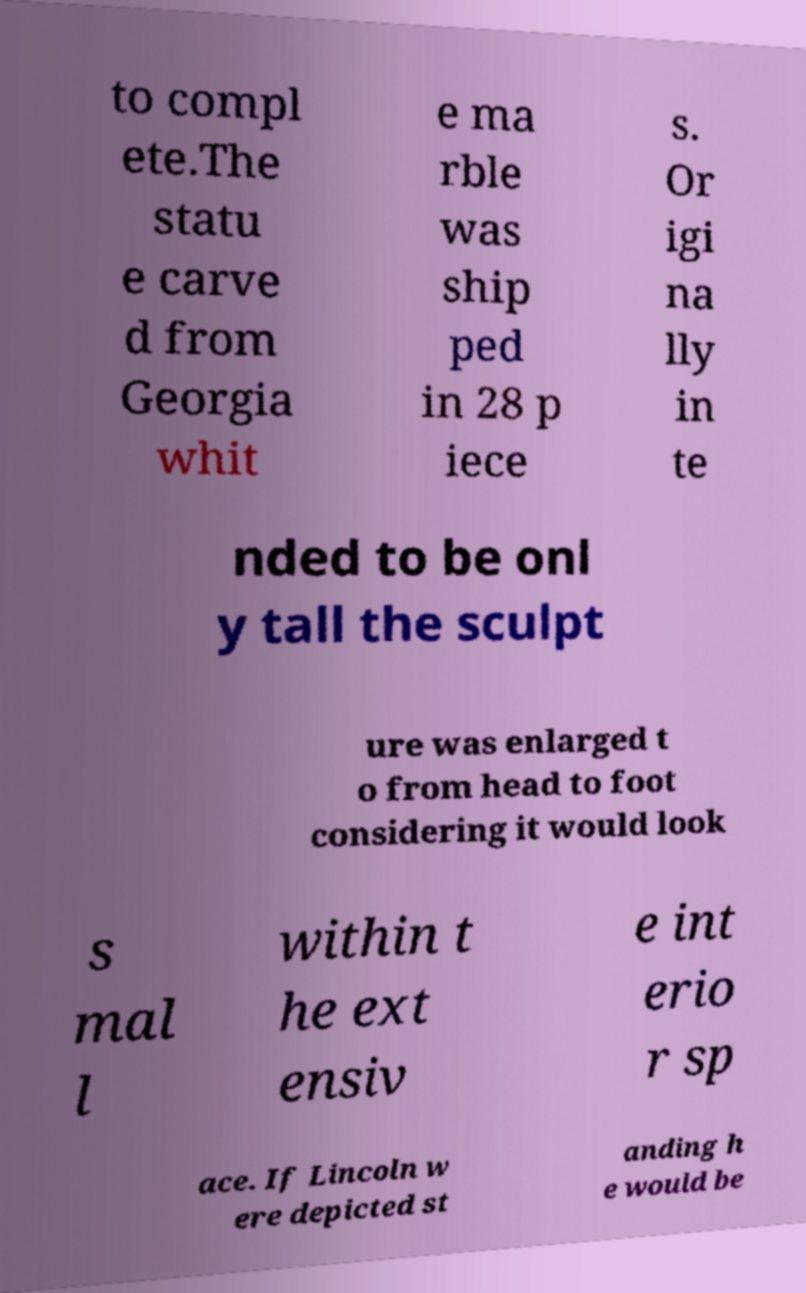For documentation purposes, I need the text within this image transcribed. Could you provide that? to compl ete.The statu e carve d from Georgia whit e ma rble was ship ped in 28 p iece s. Or igi na lly in te nded to be onl y tall the sculpt ure was enlarged t o from head to foot considering it would look s mal l within t he ext ensiv e int erio r sp ace. If Lincoln w ere depicted st anding h e would be 